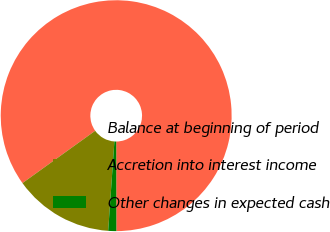Convert chart to OTSL. <chart><loc_0><loc_0><loc_500><loc_500><pie_chart><fcel>Balance at beginning of period<fcel>Accretion into interest income<fcel>Other changes in expected cash<nl><fcel>84.9%<fcel>13.97%<fcel>1.13%<nl></chart> 